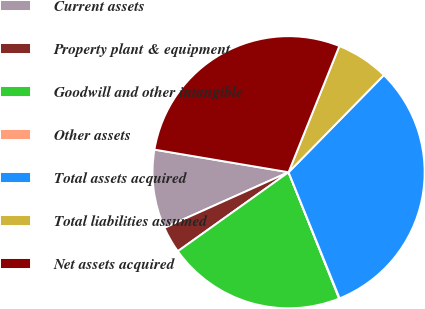Convert chart. <chart><loc_0><loc_0><loc_500><loc_500><pie_chart><fcel>Current assets<fcel>Property plant & equipment<fcel>Goodwill and other intangible<fcel>Other assets<fcel>Total assets acquired<fcel>Total liabilities assumed<fcel>Net assets acquired<nl><fcel>9.36%<fcel>3.16%<fcel>21.2%<fcel>0.06%<fcel>31.53%<fcel>6.26%<fcel>28.43%<nl></chart> 